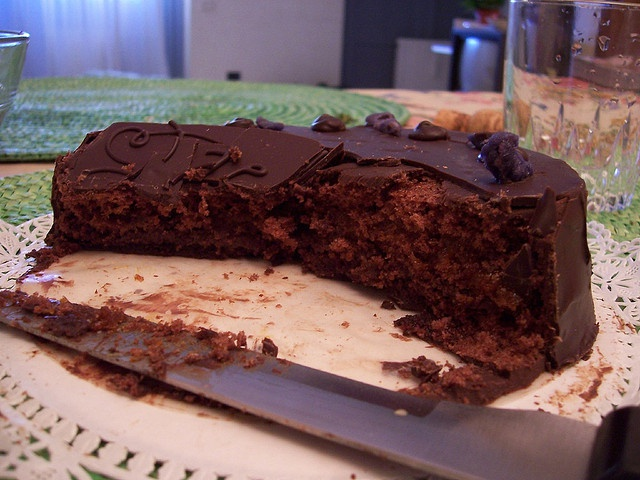Describe the objects in this image and their specific colors. I can see cake in lightblue, black, maroon, purple, and brown tones, knife in lightblue, gray, maroon, and black tones, cup in lightblue, gray, tan, and maroon tones, and bowl in lightblue and gray tones in this image. 